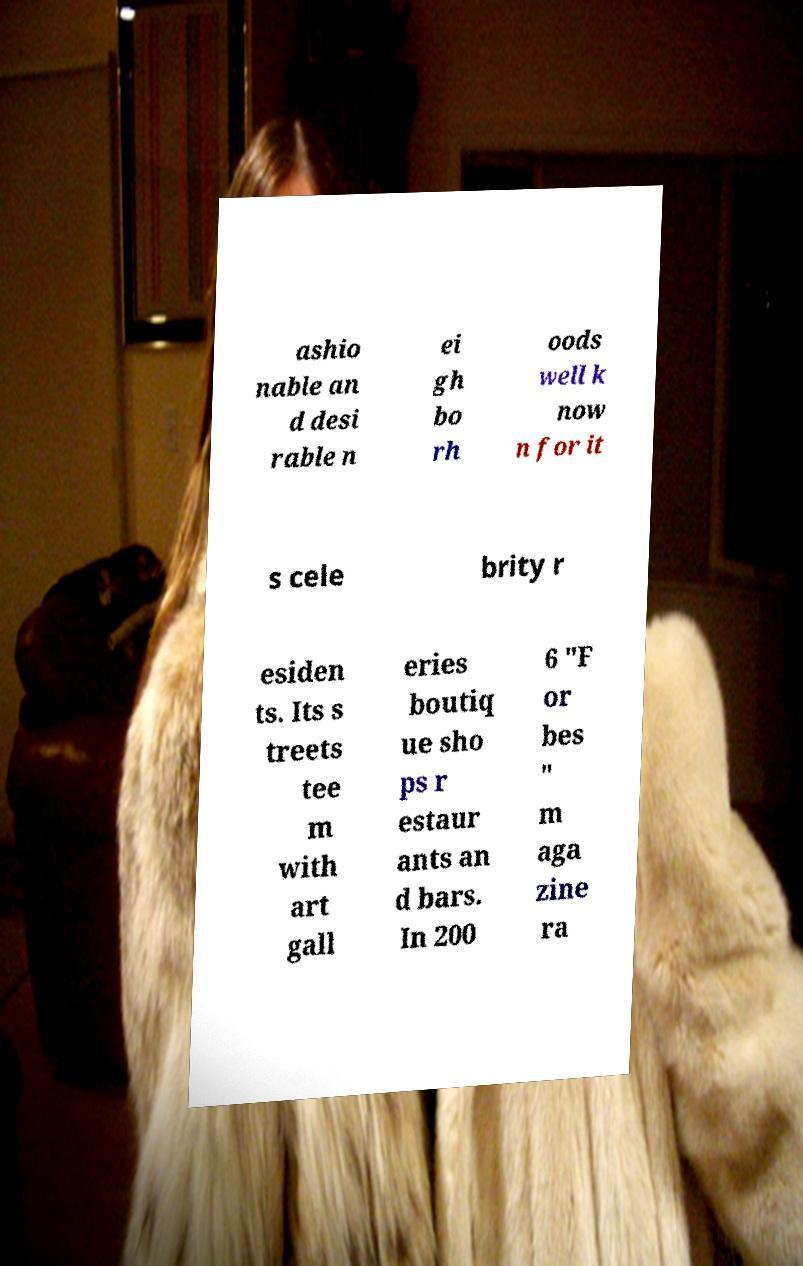Can you read and provide the text displayed in the image?This photo seems to have some interesting text. Can you extract and type it out for me? ashio nable an d desi rable n ei gh bo rh oods well k now n for it s cele brity r esiden ts. Its s treets tee m with art gall eries boutiq ue sho ps r estaur ants an d bars. In 200 6 "F or bes " m aga zine ra 